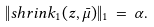<formula> <loc_0><loc_0><loc_500><loc_500>\| s h r i n k _ { 1 } ( z , \bar { \mu } ) \| _ { 1 } \, = \, \alpha .</formula> 